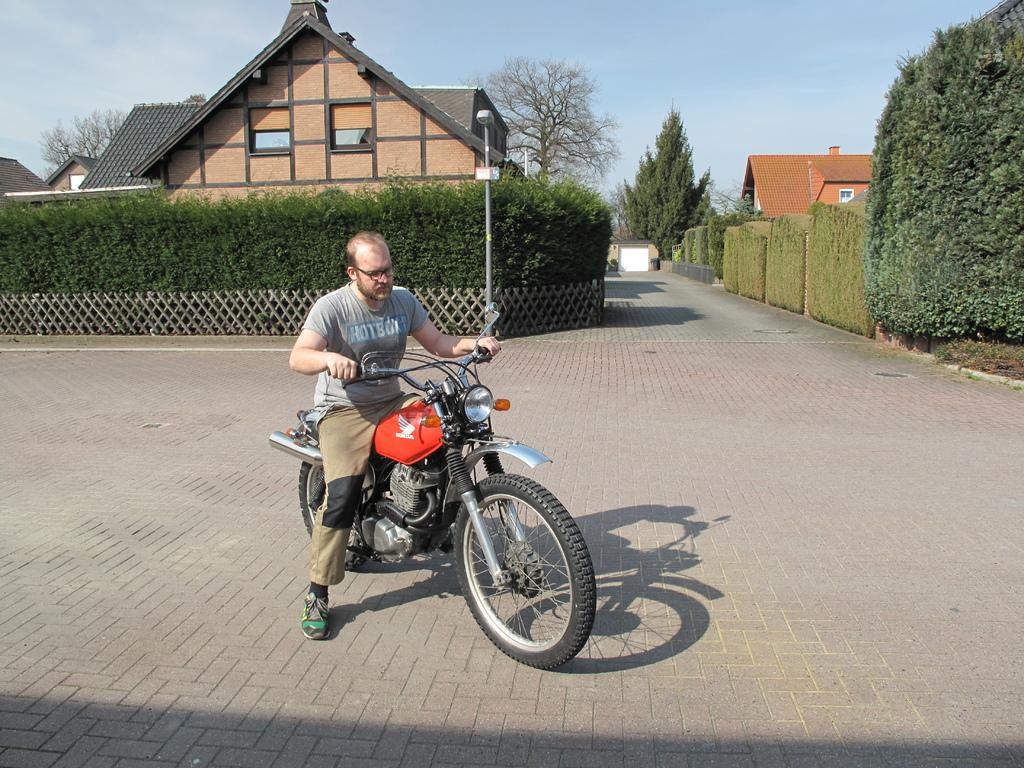What is the man doing in the image? The man is riding a bike in the street. What can be seen on either side of the lane? There are plants on either side of the lane. What is the source of light visible in the distance? There is a street light at a distance. What type of structures can be seen in the image? There are houses visible. What is the condition of the sky in the image? The sky is clear in the image. What type of zephyr is blowing through the rod in the image? There is no zephyr or rod present in the image. What emotion does the man riding the bike display in the image? The image does not show the man's emotions, so it cannot be determined from the image. 